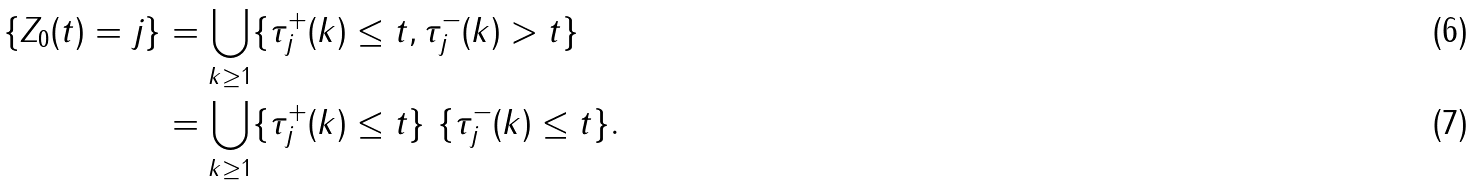<formula> <loc_0><loc_0><loc_500><loc_500>\{ Z _ { 0 } ( t ) = j \} & = \bigcup _ { k \geq 1 } \{ \tau _ { j } ^ { + } ( k ) \leq t , \tau _ { j } ^ { - } ( k ) > t \} \\ & = \bigcup _ { k \geq 1 } \{ \tau _ { j } ^ { + } ( k ) \leq t \} \ \{ \tau _ { j } ^ { - } ( k ) \leq t \} .</formula> 